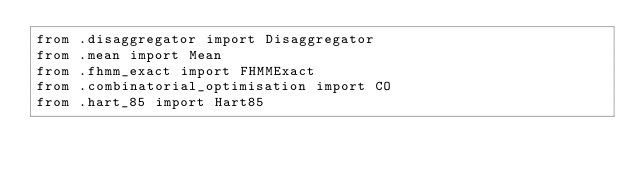<code> <loc_0><loc_0><loc_500><loc_500><_Python_>from .disaggregator import Disaggregator
from .mean import Mean
from .fhmm_exact import FHMMExact
from .combinatorial_optimisation import CO
from .hart_85 import Hart85
</code> 